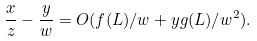<formula> <loc_0><loc_0><loc_500><loc_500>\frac { x } { z } - \frac { y } { w } = O ( f ( L ) / w + y g ( L ) / w ^ { 2 } ) .</formula> 